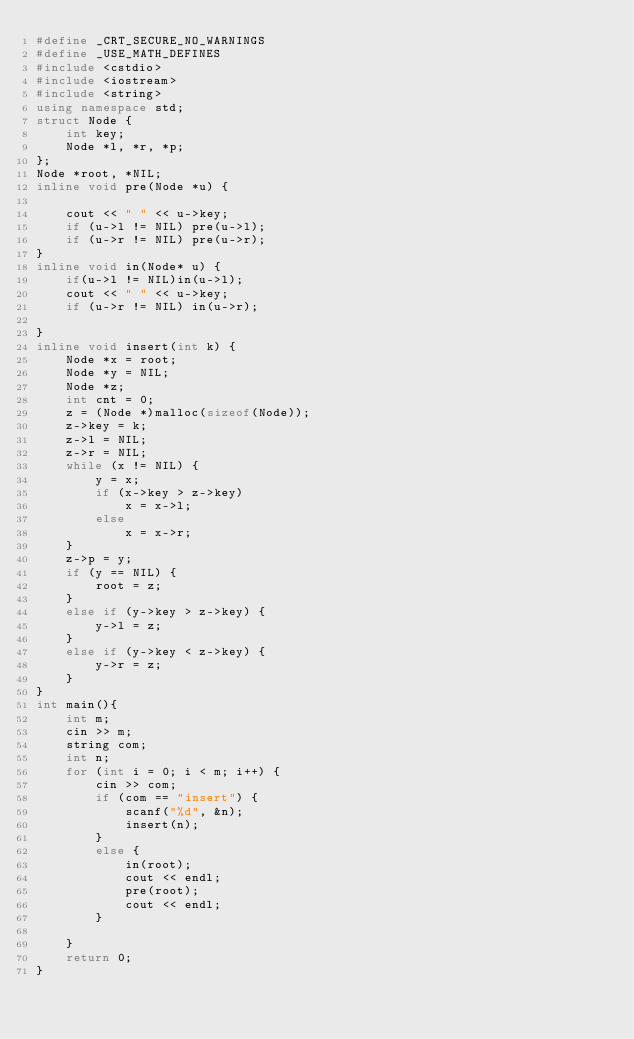Convert code to text. <code><loc_0><loc_0><loc_500><loc_500><_C++_>#define _CRT_SECURE_NO_WARNINGS
#define _USE_MATH_DEFINES
#include <cstdio>
#include <iostream>
#include <string>
using namespace std;
struct Node {
	int key;
	Node *l, *r, *p;
};
Node *root, *NIL; 
inline void pre(Node *u) {

	cout << " " << u->key;
	if (u->l != NIL) pre(u->l);
	if (u->r != NIL) pre(u->r);
}
inline void in(Node* u) {
	if(u->l != NIL)in(u->l);
	cout << " " << u->key;
	if (u->r != NIL) in(u->r);

}
inline void insert(int k) {
	Node *x = root;
	Node *y = NIL;
	Node *z;
	int cnt = 0;
	z = (Node *)malloc(sizeof(Node));
	z->key = k;
	z->l = NIL;
	z->r = NIL;
	while (x != NIL) {
		y = x;
		if (x->key > z->key)
			x = x->l;
		else
			x = x->r;
	}
	z->p = y;
	if (y == NIL) {
		root = z;
	}
	else if (y->key > z->key) {
		y->l = z;
	}
	else if (y->key < z->key) {
		y->r = z;
	}
}
int main(){
	int m;
	cin >> m;
	string com;
	int n;
	for (int i = 0; i < m; i++) {
		cin >> com;
		if (com == "insert") {
			scanf("%d", &n);
			insert(n);
		}
		else {
			in(root);
			cout << endl;
			pre(root);
			cout << endl;
		}

	}
	return 0;
}</code> 